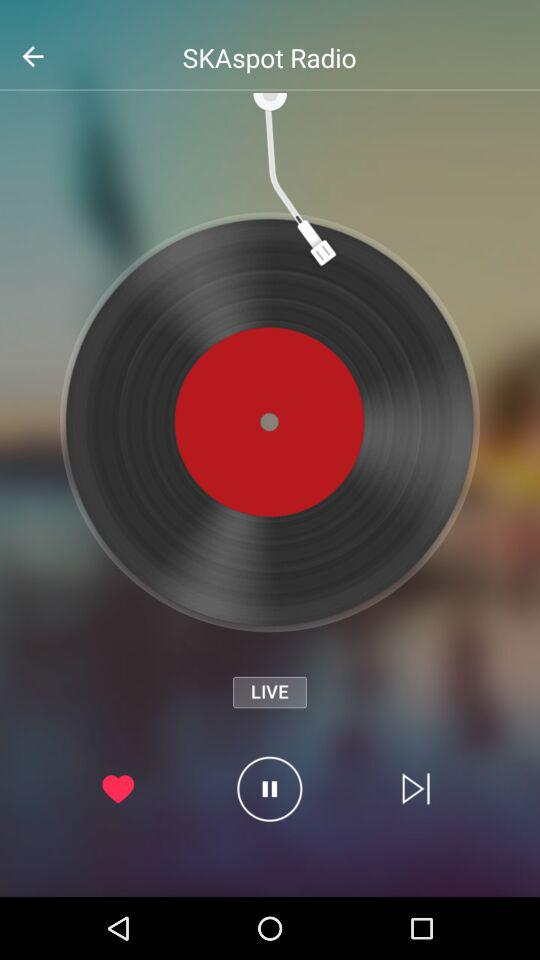How long is "SKAspot Radio"?
When the provided information is insufficient, respond with <no answer>. <no answer> 